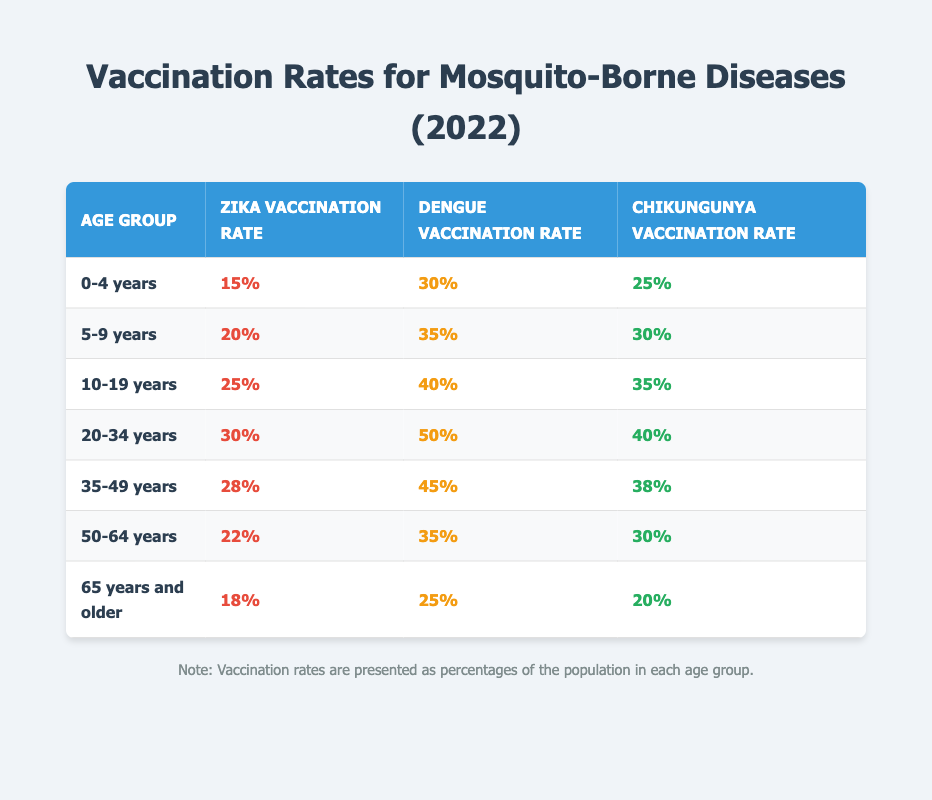What is the Zika vaccination rate for the age group 10-19 years? The table lists the Zika vaccination rate for the age group 10-19 years as 25%.
Answer: 25% What is the Dengue vaccination rate for individuals aged 65 years and older? According to the table, the Dengue vaccination rate for the age group 65 years and older is 25%.
Answer: 25% Is the Chikungunya vaccination rate higher in the age group 20-34 years compared to the age group 0-4 years? The Chikungunya vaccination rate for the age group 20-34 years is 40%, while for the age group 0-4 years it is 25%. Since 40% is greater than 25%, the statement is true.
Answer: Yes What is the average Zika vaccination rate across all age groups? To find the average, add the Zika vaccination rates (15 + 20 + 25 + 30 + 28 + 22 + 18 = 168) and divide by the number of age groups (7). The average is 168/7 = 24.
Answer: 24% Which age group has the highest Dengue vaccination rate? By examining the table, the age group 20-34 years has the highest Dengue vaccination rate of 50%.
Answer: 20-34 years Are there any age groups where the Zika vaccination rate is below 20%? The table indicates that the age groups 0-4 years (15%) and 65 years and older (18%) both have Zika vaccination rates below 20%, making this statement true.
Answer: Yes What is the difference in Chikungunya vaccination rates between the age groups 35-49 years and 50-64 years? The Chikungunya vaccination rate for 35-49 years is 38%, and for 50-64 years, it is 30%. The difference is 38% - 30% = 8%.
Answer: 8% Which age group has a higher Zika vaccination rate: 50-64 years or 65 years and older? The Zika vaccination rate for 50-64 years is 22%, while for 65 years and older it is 18%. Since 22% is greater than 18%, the age group 50-64 years has a higher rate.
Answer: 50-64 years What is the vaccination rate against Chikungunya for individuals aged 5-9 years? The Chikungunya vaccination rate for the age group 5-9 years is noted as 30% in the table.
Answer: 30% 